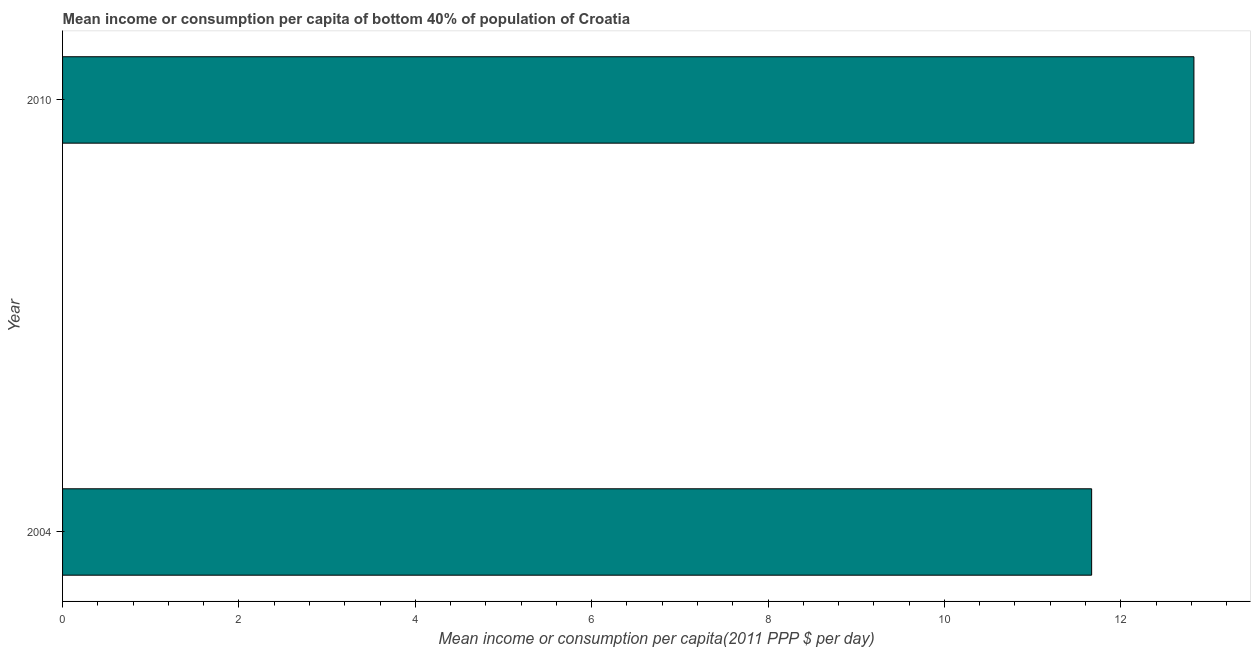What is the title of the graph?
Give a very brief answer. Mean income or consumption per capita of bottom 40% of population of Croatia. What is the label or title of the X-axis?
Give a very brief answer. Mean income or consumption per capita(2011 PPP $ per day). What is the label or title of the Y-axis?
Offer a terse response. Year. What is the mean income or consumption in 2010?
Give a very brief answer. 12.83. Across all years, what is the maximum mean income or consumption?
Offer a terse response. 12.83. Across all years, what is the minimum mean income or consumption?
Provide a succinct answer. 11.67. In which year was the mean income or consumption minimum?
Your answer should be very brief. 2004. What is the sum of the mean income or consumption?
Ensure brevity in your answer.  24.5. What is the difference between the mean income or consumption in 2004 and 2010?
Offer a terse response. -1.16. What is the average mean income or consumption per year?
Give a very brief answer. 12.25. What is the median mean income or consumption?
Your response must be concise. 12.25. In how many years, is the mean income or consumption greater than 10.4 $?
Keep it short and to the point. 2. What is the ratio of the mean income or consumption in 2004 to that in 2010?
Your answer should be compact. 0.91. Is the mean income or consumption in 2004 less than that in 2010?
Make the answer very short. Yes. In how many years, is the mean income or consumption greater than the average mean income or consumption taken over all years?
Your answer should be very brief. 1. What is the difference between two consecutive major ticks on the X-axis?
Provide a short and direct response. 2. Are the values on the major ticks of X-axis written in scientific E-notation?
Ensure brevity in your answer.  No. What is the Mean income or consumption per capita(2011 PPP $ per day) of 2004?
Provide a succinct answer. 11.67. What is the Mean income or consumption per capita(2011 PPP $ per day) of 2010?
Offer a very short reply. 12.83. What is the difference between the Mean income or consumption per capita(2011 PPP $ per day) in 2004 and 2010?
Offer a very short reply. -1.16. What is the ratio of the Mean income or consumption per capita(2011 PPP $ per day) in 2004 to that in 2010?
Make the answer very short. 0.91. 